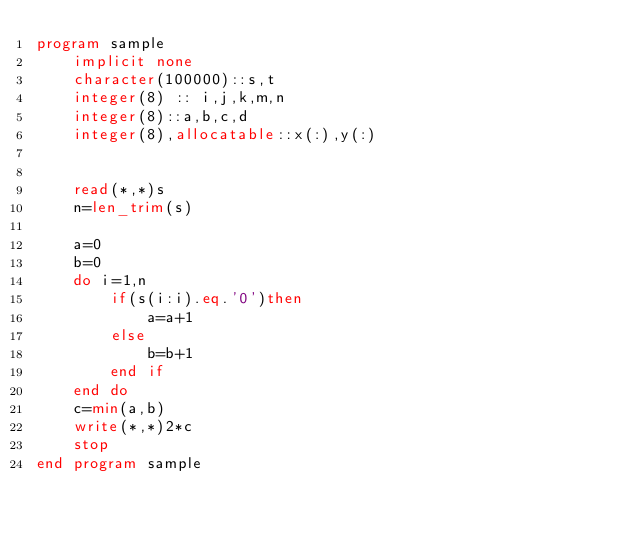<code> <loc_0><loc_0><loc_500><loc_500><_FORTRAN_>program sample
    implicit none
    character(100000)::s,t
    integer(8) :: i,j,k,m,n
    integer(8)::a,b,c,d
    integer(8),allocatable::x(:),y(:)
  
   
    read(*,*)s
    n=len_trim(s)
   
    a=0
    b=0
    do i=1,n
        if(s(i:i).eq.'0')then
            a=a+1
        else
            b=b+1
        end if
    end do
    c=min(a,b)
    write(*,*)2*c
    stop
end program sample
  

</code> 